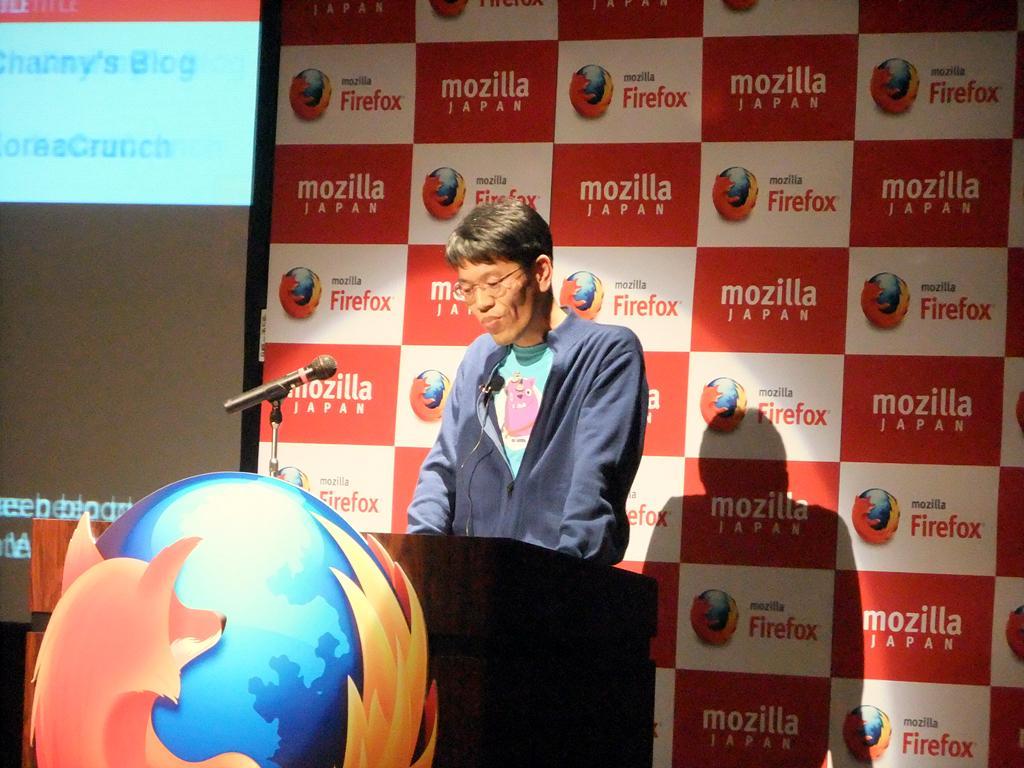Please provide a concise description of this image. In this image, I can see a person standing. In front of the person, I can see a logo and a mike to a podium. In the background, there is a screen and a board with words and logos. 